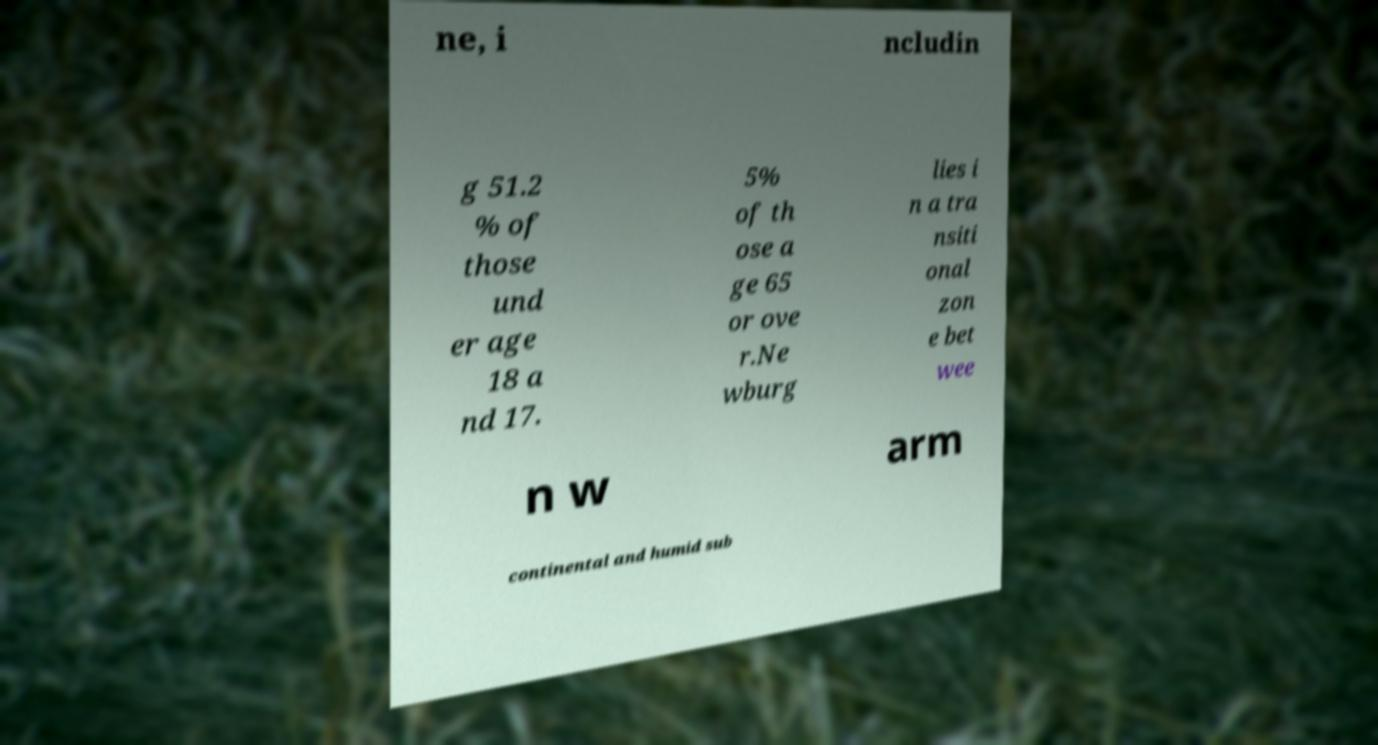Could you extract and type out the text from this image? ne, i ncludin g 51.2 % of those und er age 18 a nd 17. 5% of th ose a ge 65 or ove r.Ne wburg lies i n a tra nsiti onal zon e bet wee n w arm continental and humid sub 